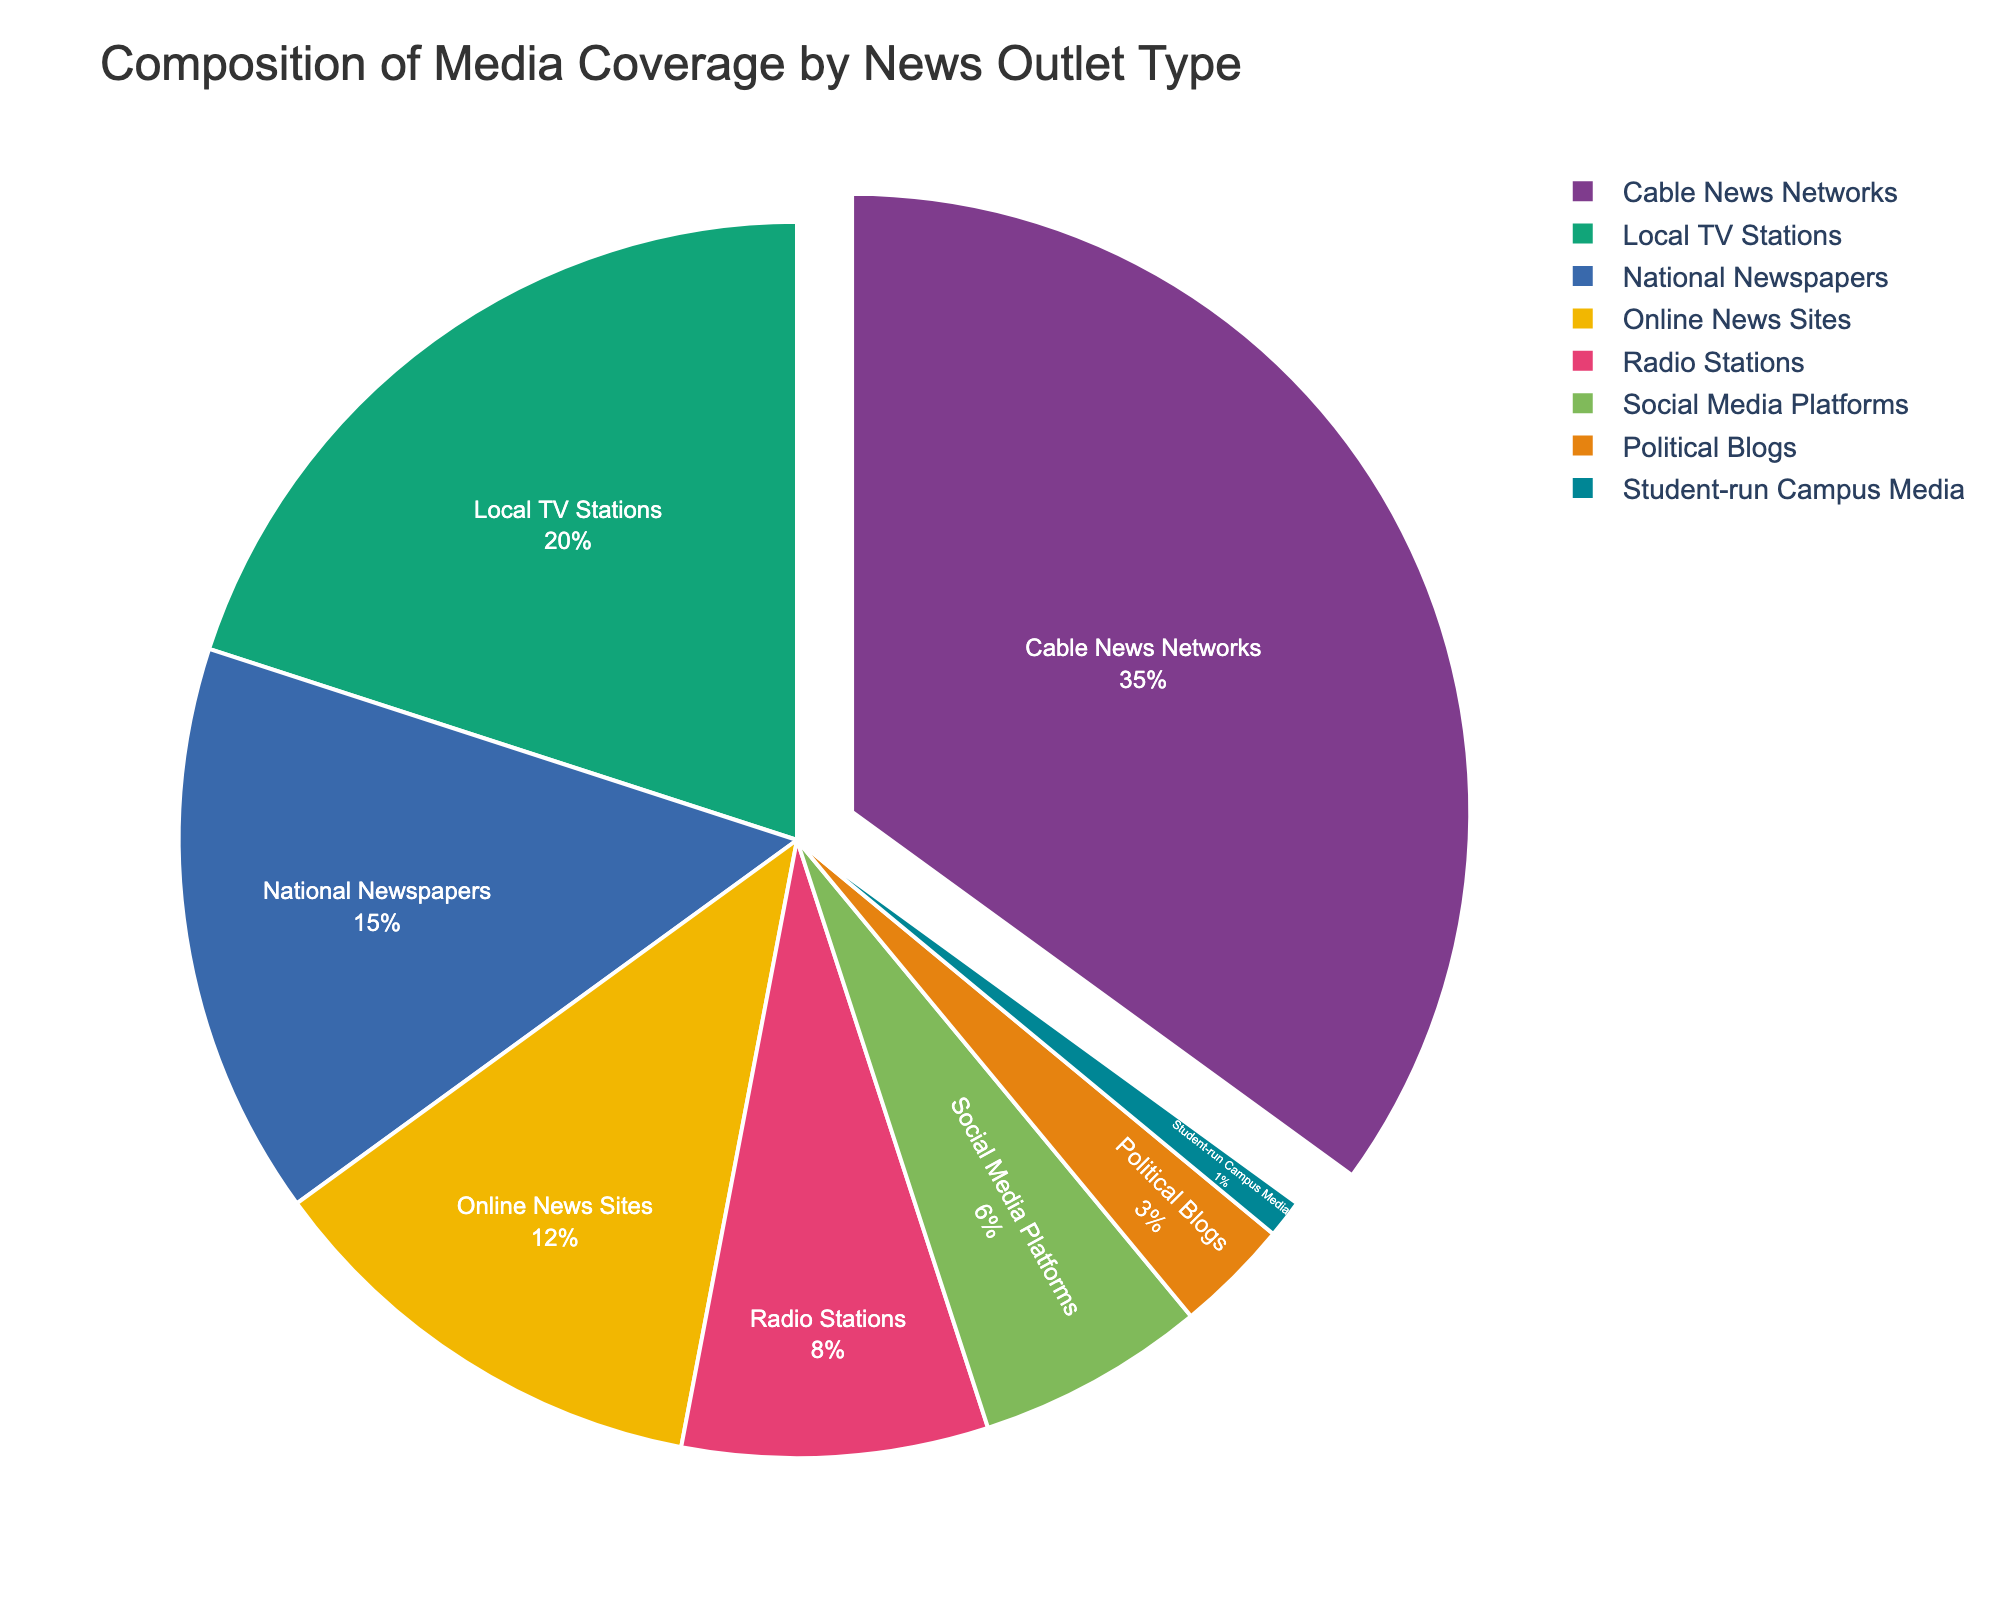What percentage of media coverage is provided by Cable News Networks and National Newspapers combined? Cable News Networks provide 35% and National Newspapers provide 15%. Adding these together gives 35% + 15% = 50%.
Answer: 50% Which news outlet type covers the second largest percentage of media coverage? Cable News Networks cover the largest percentage at 35%. The next highest is Local TV Stations at 20%.
Answer: Local TV Stations Is the percentage of media coverage by Social Media Platforms greater or less than that by Radio Stations? Social Media Platforms cover 6%, while Radio Stations cover 8%. Since 6% is less than 8%, Social Media Platforms cover less.
Answer: Less What is the difference in media coverage percentage between Online News Sites and Political Blogs? Online News Sites cover 12%, and Political Blogs cover 3%. The difference is 12% - 3% = 9%.
Answer: 9% What is the combined percentage of media coverage from Radio Stations, Social Media Platforms, Political Blogs, and Student-run Campus Media? Adding the percentages: 8% (Radio Stations) + 6% (Social Media Platforms) + 3% (Political Blogs) + 1% (Student-run Campus Media) = 18%.
Answer: 18% Which news outlet type has the smallest percentage of media coverage? The type with the smallest percentage is Student-run Campus Media, which has 1%.
Answer: Student-run Campus Media How much more media coverage percentage do Cable News Networks have compared to Online News Sites? Cable News Networks have 35%, and Online News Sites have 12%. The difference is 35% - 12% = 23%.
Answer: 23% If we group Local TV Stations, Radio Stations, and Student-run Campus Media as traditional media, what is their combined percentage of media coverage? Local TV Stations cover 20%, Radio Stations cover 8%, and Student-run Campus Media cover 1%. Summing these gives 20% + 8% + 1% = 29%.
Answer: 29% Which color represents National Newspapers in the pie chart? The specific color palette is not described, but by interpreting the figure's legend, we can identify the color assigned to National Newspapers.
Answer: (Depends on the figure) Compare the combined media coverage percentage of Social Media Platforms and Online News Sites to Local TV Stations. Is it greater or less? Social Media Platforms cover 6%, and Online News Sites cover 12%. Combined, this is 6% + 12% = 18%. Local TV Stations cover 20%. So 18% is less than 20%.
Answer: Less 